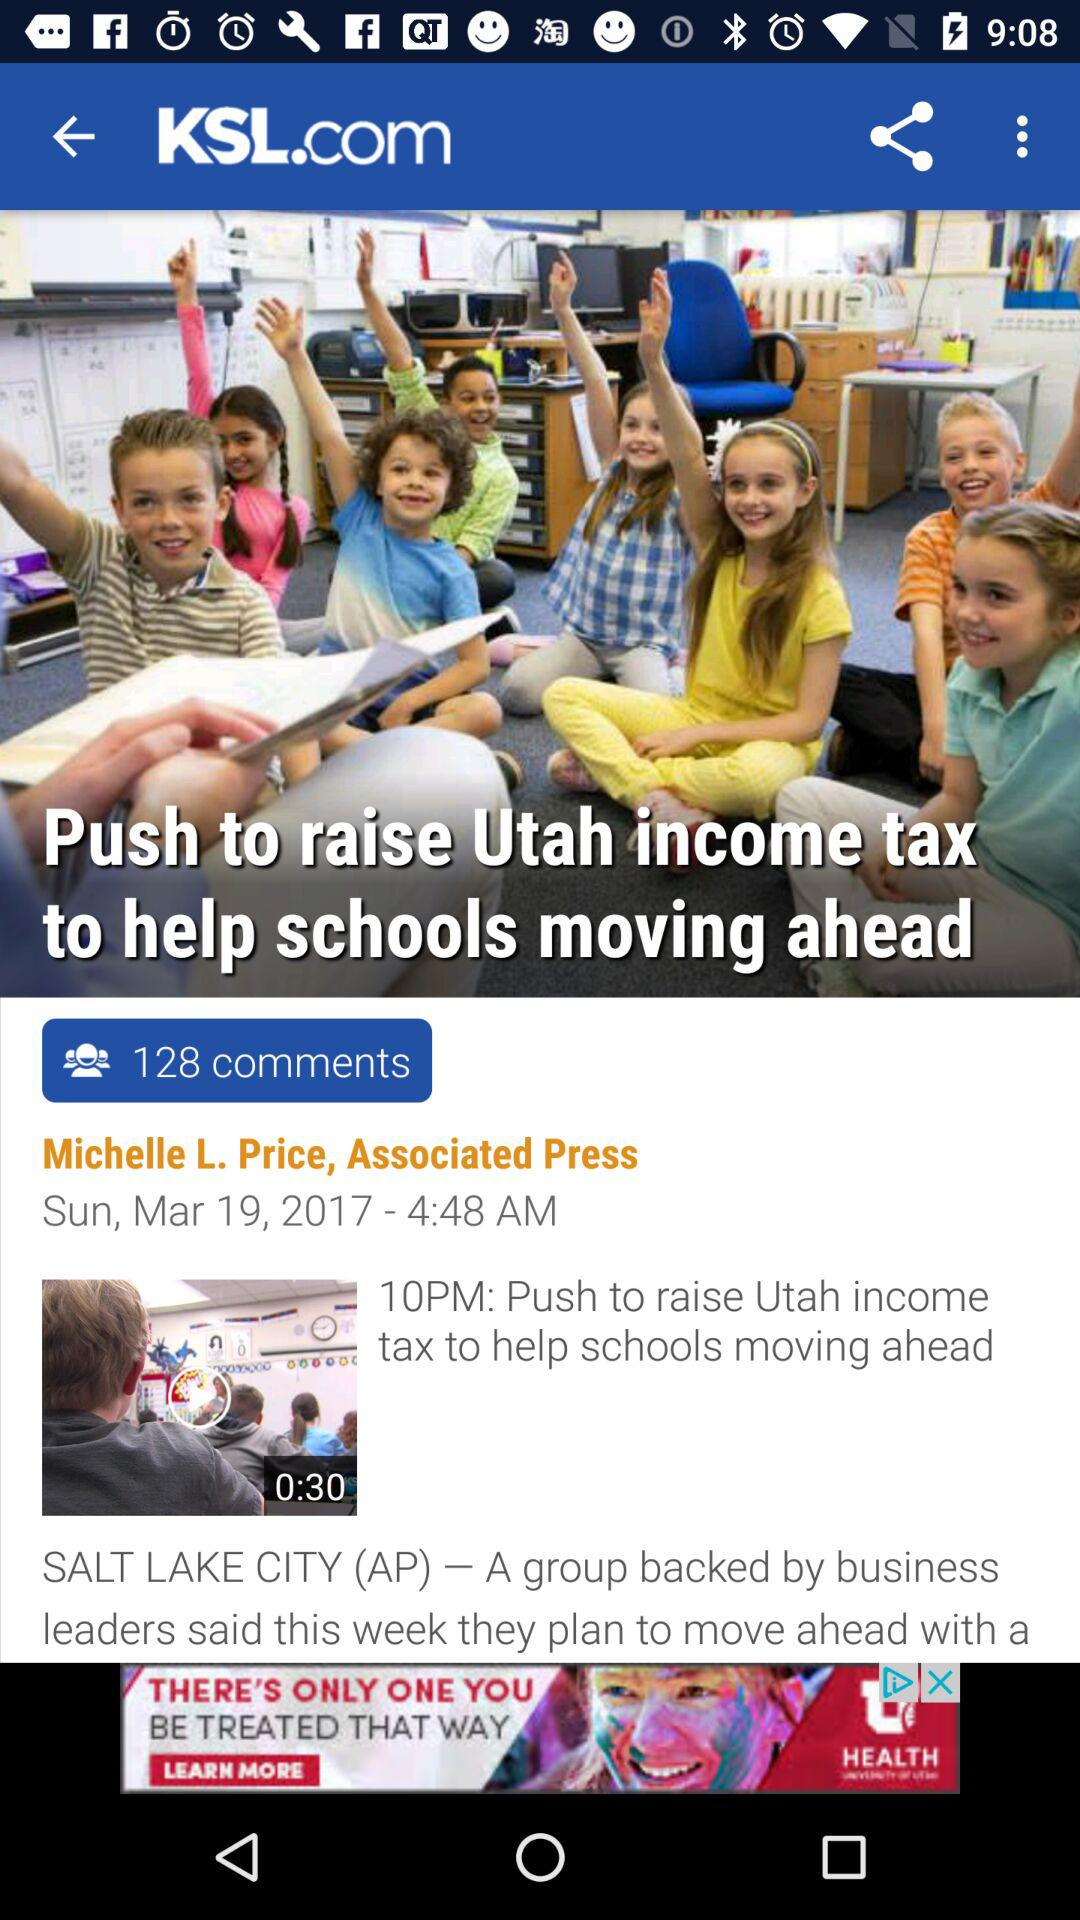What is the website name where the article is posted? The website is "KSL.com". 